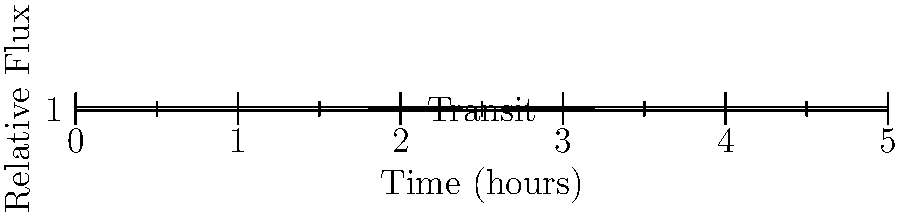Given the light curve of an exoplanet transit shown above, estimate the transit duration and the planet's orbital period if this star-planet system is observed continuously for 30 days and 6 similar transits are detected. Assume circular orbit and that the planet's orbital plane is edge-on to our line of sight. To solve this problem, we'll follow these steps:

1. Estimate the transit duration from the graph:
   The flux drops below 1 at about t = 1.75 hours and returns to 1 at about t = 3.25 hours.
   Transit duration ≈ 3.25 - 1.75 = 1.5 hours

2. Calculate the orbital period:
   - We observe 6 transits in 30 days
   - Orbital period = Total observation time / Number of transits
   - Orbital period = 30 days / 6 = 5 days

3. Convert the orbital period to hours for consistency:
   5 days * 24 hours/day = 120 hours

4. Verify the result using the transit duration to orbital period ratio:
   For a circular orbit and edge-on view, the ratio of transit duration to orbital period is approximately equal to the ratio of the star's diameter to the orbital circumference.
   
   $\frac{\text{Transit duration}}{\text{Orbital period}} \approx \frac{1.5 \text{ hours}}{120 \text{ hours}} = 0.0125$

   This is a reasonable value for a close-in exoplanet, supporting our calculation.
Answer: Transit duration: 1.5 hours; Orbital period: 120 hours (5 days) 